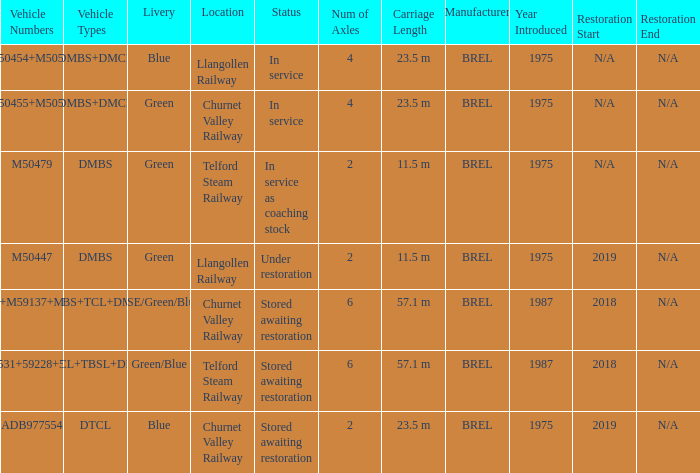What livery has a status of in service as coaching stock? Green. 